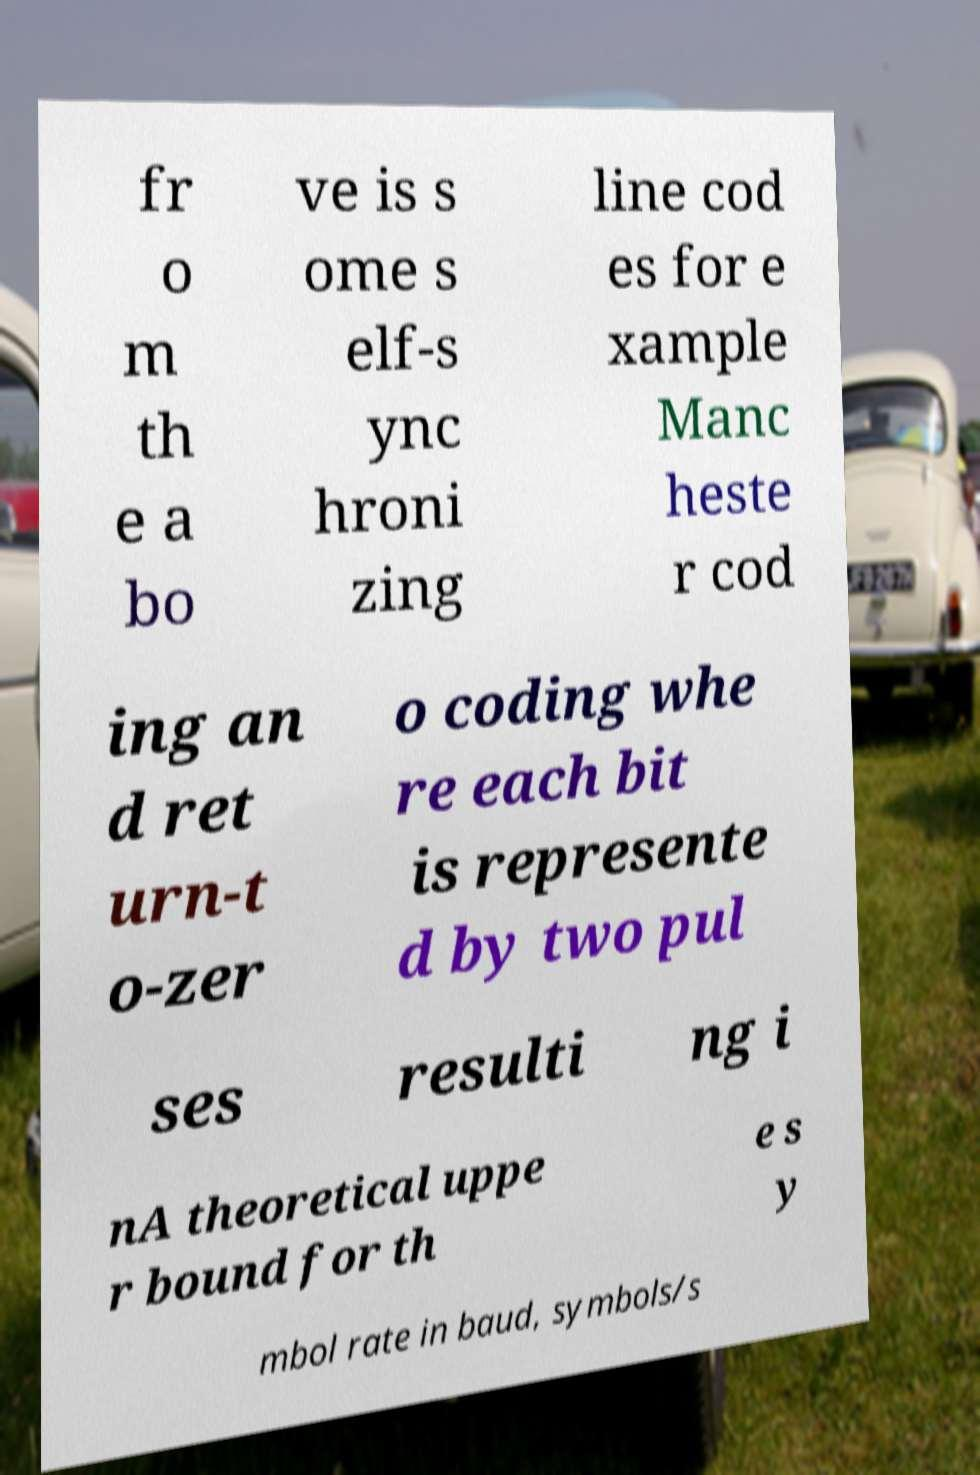Could you extract and type out the text from this image? fr o m th e a bo ve is s ome s elf-s ync hroni zing line cod es for e xample Manc heste r cod ing an d ret urn-t o-zer o coding whe re each bit is represente d by two pul ses resulti ng i nA theoretical uppe r bound for th e s y mbol rate in baud, symbols/s 